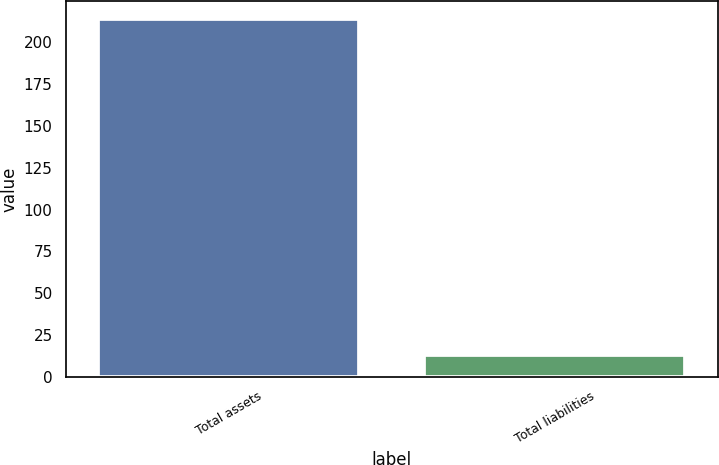Convert chart to OTSL. <chart><loc_0><loc_0><loc_500><loc_500><bar_chart><fcel>Total assets<fcel>Total liabilities<nl><fcel>214<fcel>13<nl></chart> 